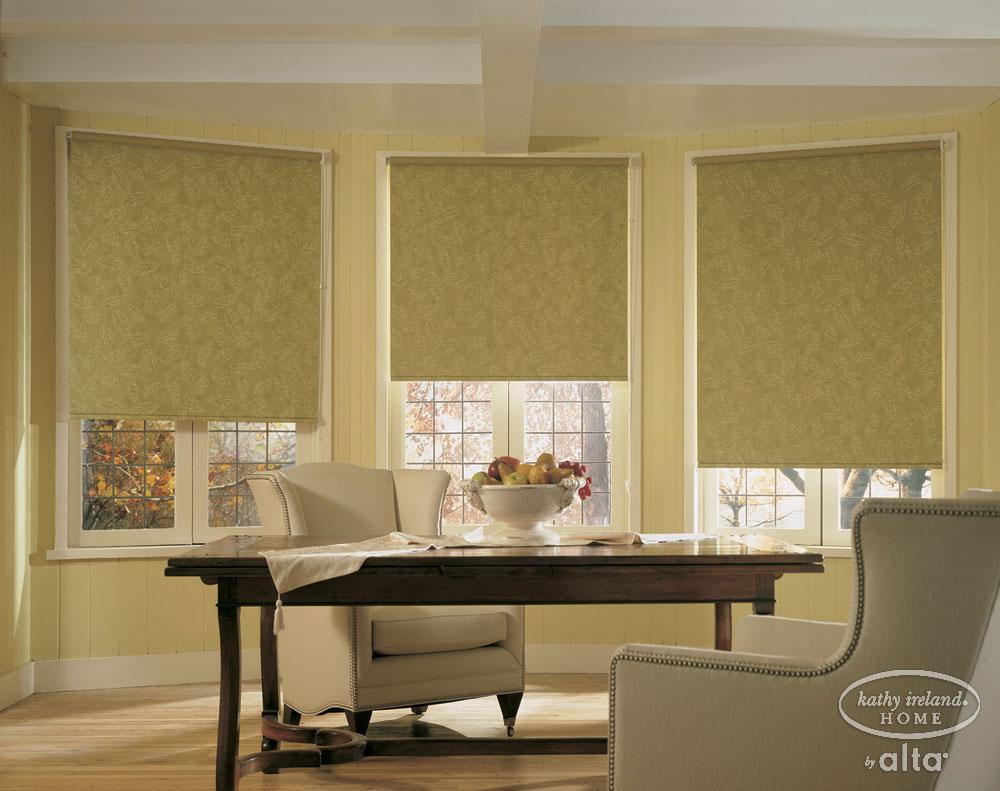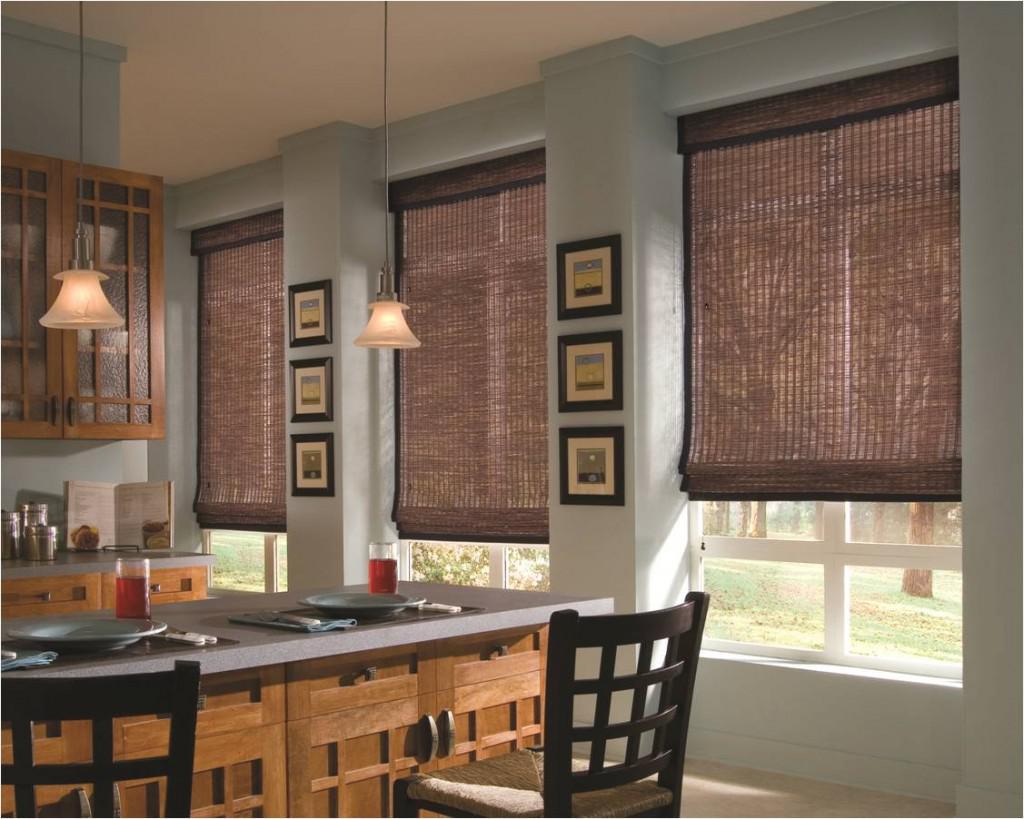The first image is the image on the left, the second image is the image on the right. Assess this claim about the two images: "There are exactly six window shades.". Correct or not? Answer yes or no. Yes. The first image is the image on the left, the second image is the image on the right. For the images displayed, is the sentence "There are a total of six blinds." factually correct? Answer yes or no. Yes. 